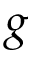<formula> <loc_0><loc_0><loc_500><loc_500>g</formula> 